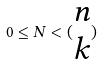Convert formula to latex. <formula><loc_0><loc_0><loc_500><loc_500>0 \leq N < ( \begin{matrix} n \\ k \end{matrix} )</formula> 